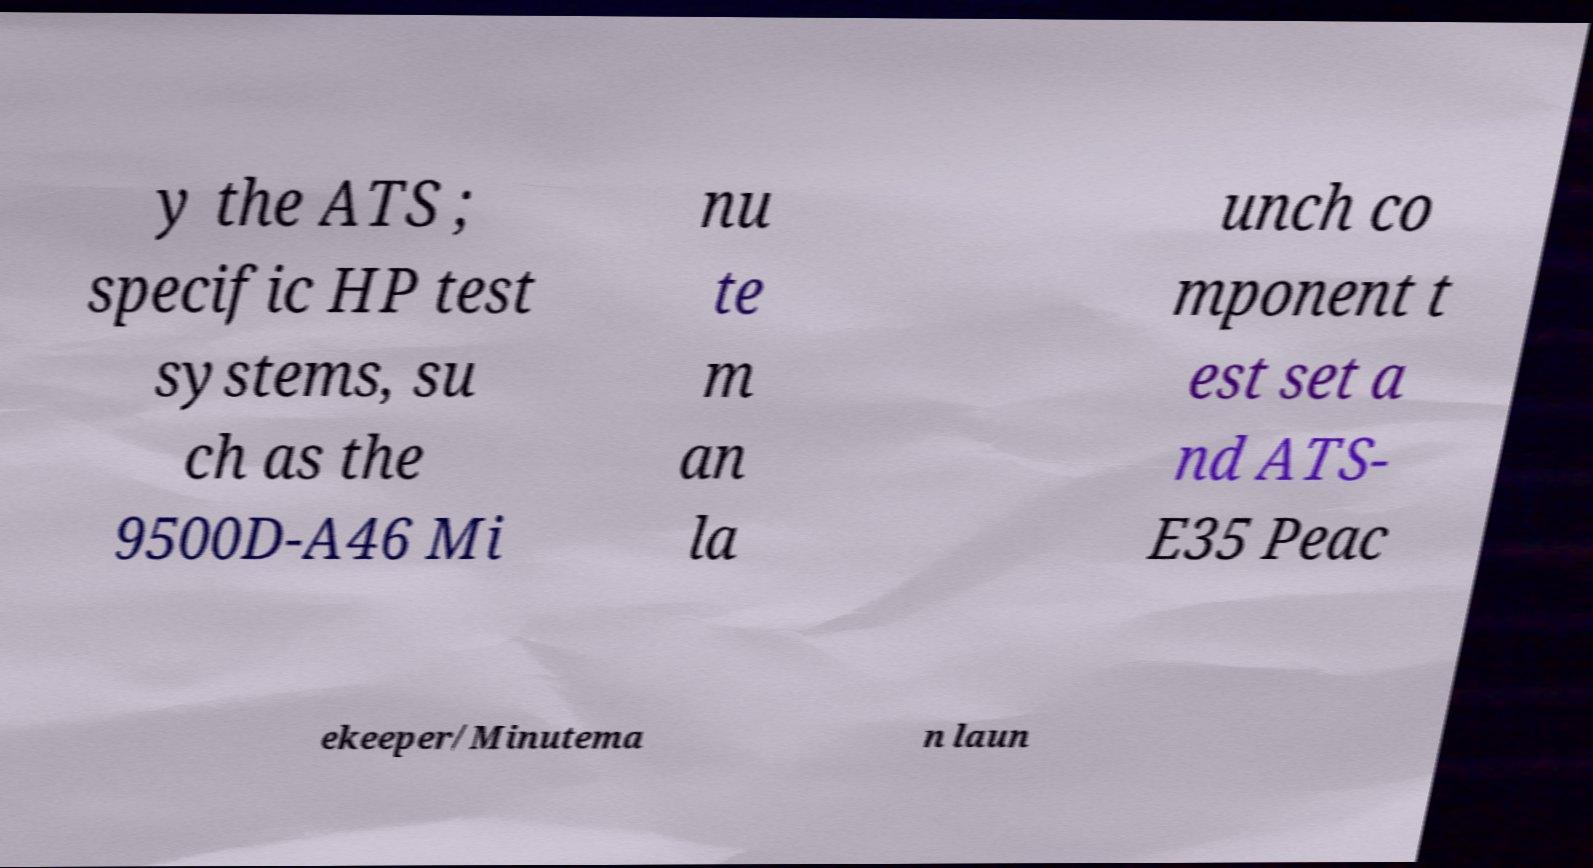What messages or text are displayed in this image? I need them in a readable, typed format. y the ATS ; specific HP test systems, su ch as the 9500D-A46 Mi nu te m an la unch co mponent t est set a nd ATS- E35 Peac ekeeper/Minutema n laun 